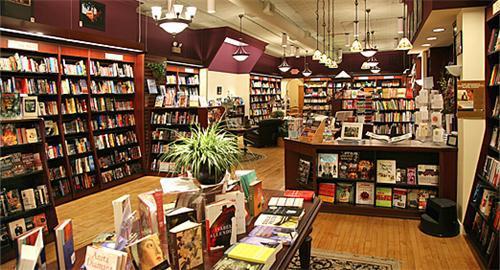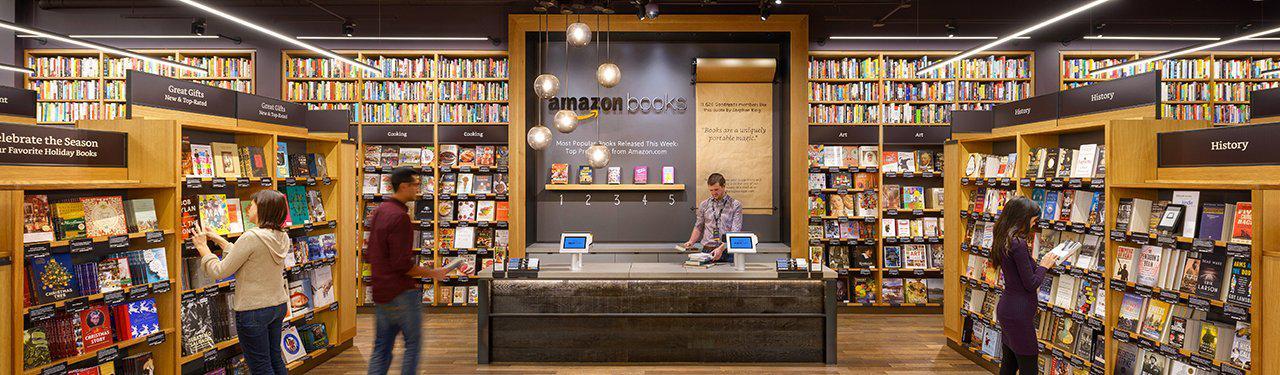The first image is the image on the left, the second image is the image on the right. For the images shown, is this caption "There are no more than 4 people in the image on the right." true? Answer yes or no. Yes. 